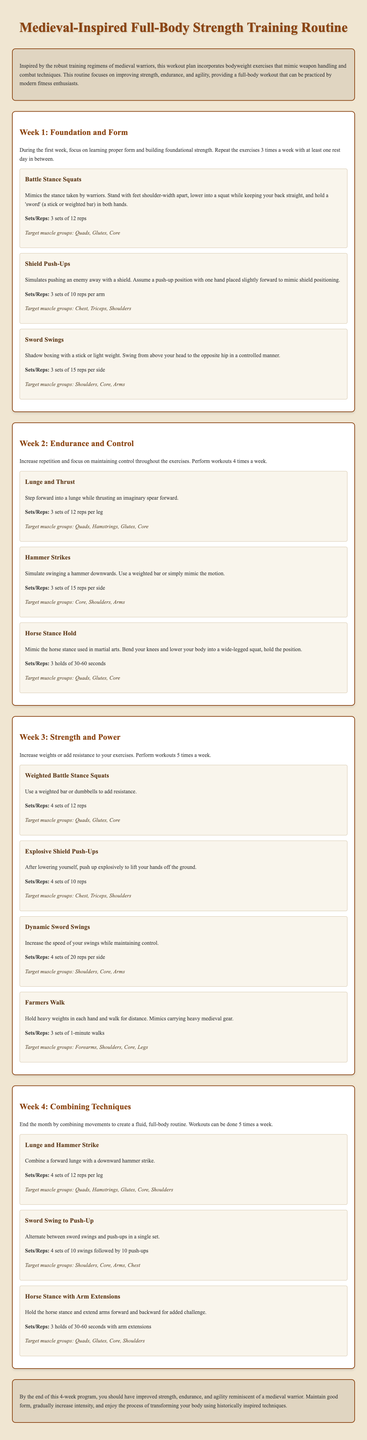What is the title of the document? The title, as presented at the top of the document, indicates the focus and content of the workout plan.
Answer: Medieval-Inspired Full-Body Strength Training Routine How many weeks does the workout plan cover? The document outlines the plan broken down into weekly sections, specifically identifying the duration of the program.
Answer: 4 weeks What is the target muscle group for Battle Stance Squats? The text specifies which muscle groups are engaged during each exercise, including the Battle Stance Squats.
Answer: Quads, Glutes, Core How many sets and reps are recommended for Horse Stance Hold in Week 2? The specific details about sets and repetitions for each exercise are clearly stated in their respective sections.
Answer: 3 holds of 30-60 seconds What type of exercise is Shield Push-Ups classified as? The document categorizes exercises under specific movement types, showcasing their original combat inspirations.
Answer: Push-up What additional resistance is suggested for Week 3 exercises? The progression in the workout routine advises increasing the difficulty of exercises as time goes on.
Answer: Weights or resistance How many times should exercises be performed during Week 1? The document specifies the workout frequency for each week, particularly for the initial week.
Answer: 3 times a week What combination of exercises is proposed in Week 4? Week 4 includes exercises that integrate movements from previous weeks for a more complex routine.
Answer: Lunge and Hammer Strike 